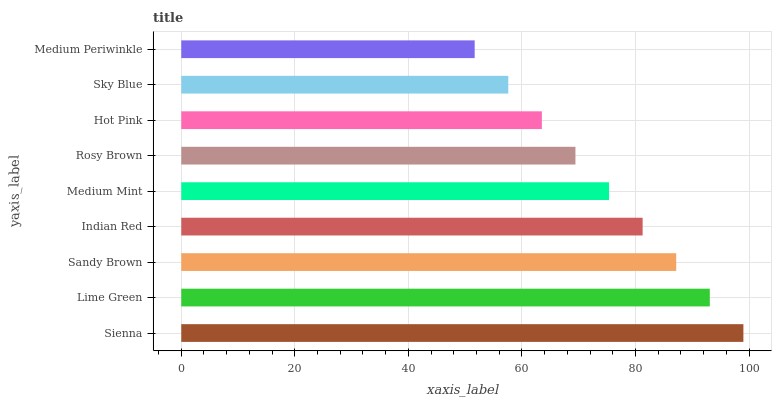Is Medium Periwinkle the minimum?
Answer yes or no. Yes. Is Sienna the maximum?
Answer yes or no. Yes. Is Lime Green the minimum?
Answer yes or no. No. Is Lime Green the maximum?
Answer yes or no. No. Is Sienna greater than Lime Green?
Answer yes or no. Yes. Is Lime Green less than Sienna?
Answer yes or no. Yes. Is Lime Green greater than Sienna?
Answer yes or no. No. Is Sienna less than Lime Green?
Answer yes or no. No. Is Medium Mint the high median?
Answer yes or no. Yes. Is Medium Mint the low median?
Answer yes or no. Yes. Is Indian Red the high median?
Answer yes or no. No. Is Sienna the low median?
Answer yes or no. No. 